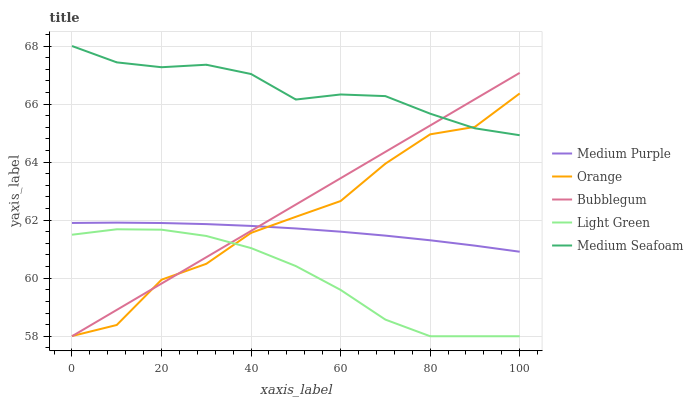Does Light Green have the minimum area under the curve?
Answer yes or no. Yes. Does Medium Seafoam have the maximum area under the curve?
Answer yes or no. Yes. Does Orange have the minimum area under the curve?
Answer yes or no. No. Does Orange have the maximum area under the curve?
Answer yes or no. No. Is Bubblegum the smoothest?
Answer yes or no. Yes. Is Orange the roughest?
Answer yes or no. Yes. Is Light Green the smoothest?
Answer yes or no. No. Is Light Green the roughest?
Answer yes or no. No. Does Light Green have the lowest value?
Answer yes or no. Yes. Does Orange have the lowest value?
Answer yes or no. No. Does Medium Seafoam have the highest value?
Answer yes or no. Yes. Does Orange have the highest value?
Answer yes or no. No. Is Light Green less than Medium Purple?
Answer yes or no. Yes. Is Medium Seafoam greater than Medium Purple?
Answer yes or no. Yes. Does Bubblegum intersect Light Green?
Answer yes or no. Yes. Is Bubblegum less than Light Green?
Answer yes or no. No. Is Bubblegum greater than Light Green?
Answer yes or no. No. Does Light Green intersect Medium Purple?
Answer yes or no. No. 